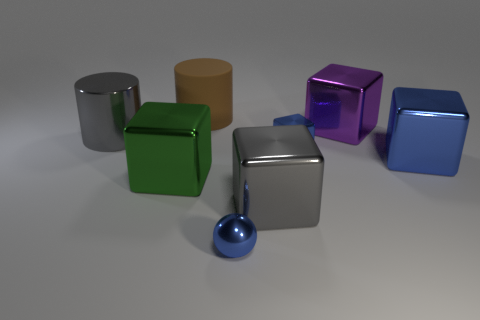Subtract all green balls. How many blue blocks are left? 2 Subtract all small metallic cubes. How many cubes are left? 4 Subtract all gray cubes. How many cubes are left? 4 Subtract all red blocks. Subtract all purple cylinders. How many blocks are left? 5 Add 2 small blue things. How many objects exist? 10 Subtract all spheres. How many objects are left? 7 Subtract all green metal objects. Subtract all big gray balls. How many objects are left? 7 Add 4 brown objects. How many brown objects are left? 5 Add 3 big blocks. How many big blocks exist? 7 Subtract 0 cyan cylinders. How many objects are left? 8 